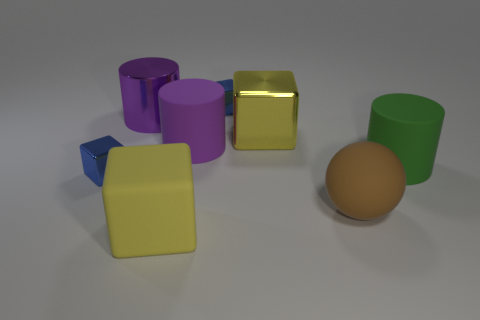Is there a green cylinder that has the same material as the green thing?
Offer a very short reply. No. The shiny object that is the same color as the big rubber cube is what size?
Your response must be concise. Large. How many cylinders are either brown rubber objects or small blue metal objects?
Keep it short and to the point. 0. Are there more shiny things behind the metallic cylinder than spheres that are right of the big brown matte sphere?
Give a very brief answer. Yes. What number of other large cylinders have the same color as the metallic cylinder?
Your answer should be compact. 1. The purple object that is made of the same material as the sphere is what size?
Your answer should be very brief. Large. How many things are either small blue things that are in front of the purple metallic cylinder or blocks?
Provide a succinct answer. 4. Is the color of the block that is in front of the brown rubber sphere the same as the metal cylinder?
Make the answer very short. No. The yellow matte object that is the same shape as the yellow metallic object is what size?
Keep it short and to the point. Large. What is the color of the metallic block in front of the yellow cube behind the large cylinder right of the brown matte thing?
Your answer should be compact. Blue. 